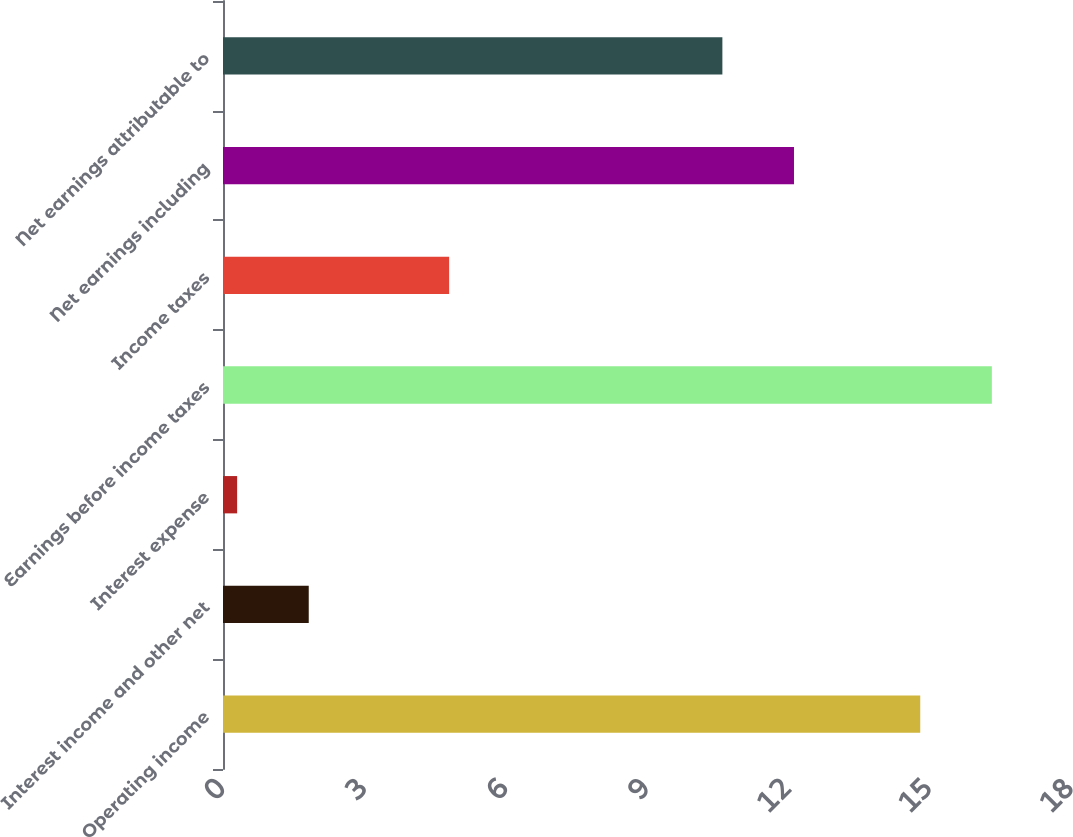Convert chart to OTSL. <chart><loc_0><loc_0><loc_500><loc_500><bar_chart><fcel>Operating income<fcel>Interest income and other net<fcel>Interest expense<fcel>Earnings before income taxes<fcel>Income taxes<fcel>Net earnings including<fcel>Net earnings attributable to<nl><fcel>14.8<fcel>1.82<fcel>0.3<fcel>16.32<fcel>4.8<fcel>12.12<fcel>10.6<nl></chart> 